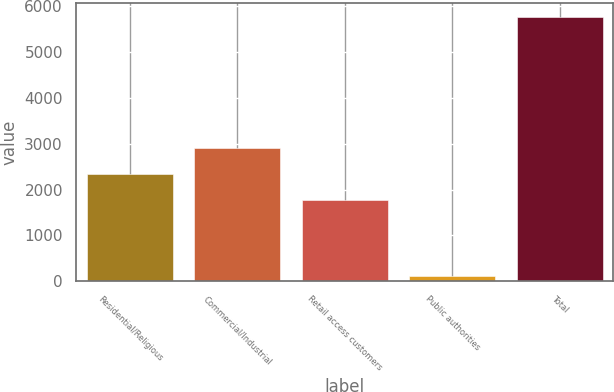Convert chart to OTSL. <chart><loc_0><loc_0><loc_500><loc_500><bar_chart><fcel>Residential/Religious<fcel>Commercial/Industrial<fcel>Retail access customers<fcel>Public authorities<fcel>Total<nl><fcel>2331.2<fcel>2897.4<fcel>1765<fcel>114<fcel>5776<nl></chart> 